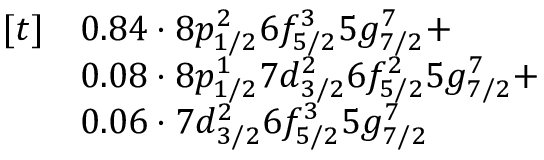<formula> <loc_0><loc_0><loc_500><loc_500>\begin{array} { r l } { [ t ] } & { 0 . 8 4 \cdot 8 p _ { 1 / 2 } ^ { 2 } 6 f _ { 5 / 2 } ^ { 3 } 5 g _ { 7 / 2 } ^ { 7 } + } \\ & { 0 . 0 8 \cdot 8 p _ { 1 / 2 } ^ { 1 } 7 d _ { 3 / 2 } ^ { 2 } 6 f _ { 5 / 2 } ^ { 2 } 5 g _ { 7 / 2 } ^ { 7 } + } \\ & { 0 . 0 6 \cdot 7 d _ { 3 / 2 } ^ { 2 } 6 f _ { 5 / 2 } ^ { 3 } 5 g _ { 7 / 2 } ^ { 7 } } \end{array}</formula> 